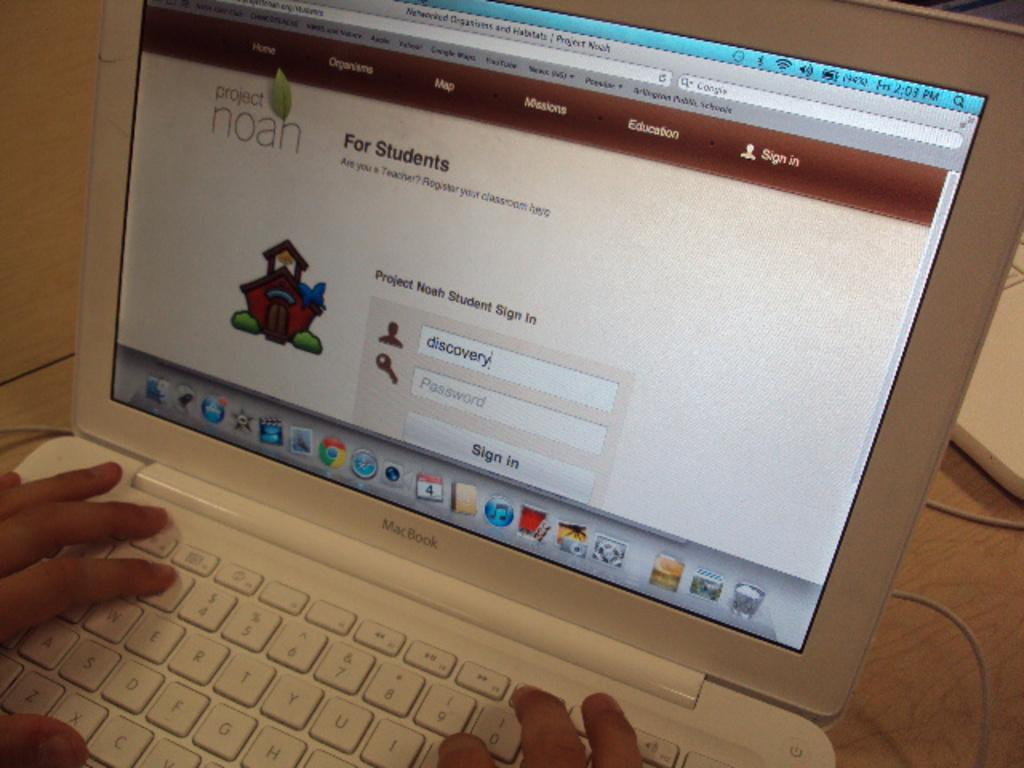<image>
Summarize the visual content of the image. A laptop is open to a page titled "Project Noah" and someone is logging in as "discovery." 